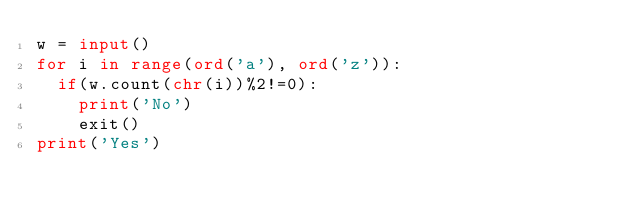<code> <loc_0><loc_0><loc_500><loc_500><_Python_>w = input()
for i in range(ord('a'), ord('z')):
  if(w.count(chr(i))%2!=0):
    print('No')
    exit()
print('Yes')</code> 